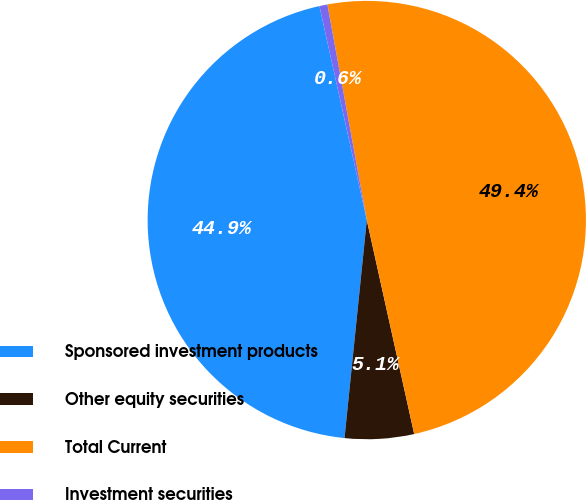<chart> <loc_0><loc_0><loc_500><loc_500><pie_chart><fcel>Sponsored investment products<fcel>Other equity securities<fcel>Total Current<fcel>Investment securities<nl><fcel>44.91%<fcel>5.09%<fcel>49.41%<fcel>0.59%<nl></chart> 